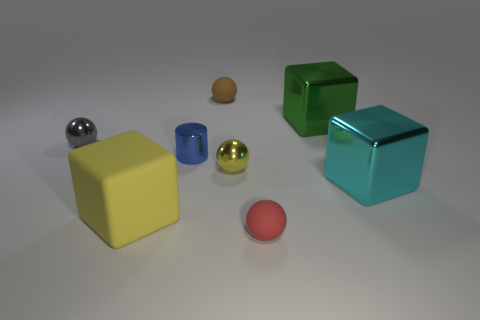How would you associate the colors of the objects with their shapes? Each object's color seems to have been chosen to compliment its shape and texture. The bright yellow and cyan hues accentuate the simplicity and the straight edges of the cubes, while the reflective properties of the green cube are highlighted by its deep, rich color. The metallic spheres in silver and gold draw attention to their seamless curves and reflective surfaces. The matte finish of the smaller brown and the red sphere reveal their colors more subtlety, which pairs well with their unadorned round shapes. 